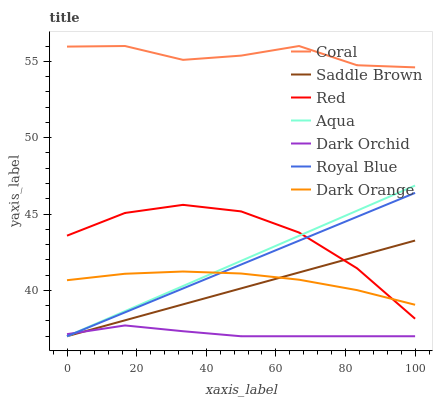Does Dark Orchid have the minimum area under the curve?
Answer yes or no. Yes. Does Coral have the maximum area under the curve?
Answer yes or no. Yes. Does Aqua have the minimum area under the curve?
Answer yes or no. No. Does Aqua have the maximum area under the curve?
Answer yes or no. No. Is Aqua the smoothest?
Answer yes or no. Yes. Is Coral the roughest?
Answer yes or no. Yes. Is Coral the smoothest?
Answer yes or no. No. Is Aqua the roughest?
Answer yes or no. No. Does Aqua have the lowest value?
Answer yes or no. Yes. Does Coral have the lowest value?
Answer yes or no. No. Does Coral have the highest value?
Answer yes or no. Yes. Does Aqua have the highest value?
Answer yes or no. No. Is Dark Orchid less than Dark Orange?
Answer yes or no. Yes. Is Coral greater than Red?
Answer yes or no. Yes. Does Saddle Brown intersect Dark Orchid?
Answer yes or no. Yes. Is Saddle Brown less than Dark Orchid?
Answer yes or no. No. Is Saddle Brown greater than Dark Orchid?
Answer yes or no. No. Does Dark Orchid intersect Dark Orange?
Answer yes or no. No. 